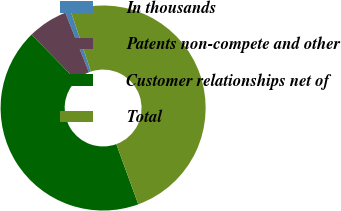Convert chart to OTSL. <chart><loc_0><loc_0><loc_500><loc_500><pie_chart><fcel>In thousands<fcel>Patents non-compete and other<fcel>Customer relationships net of<fcel>Total<nl><fcel>0.88%<fcel>6.28%<fcel>43.28%<fcel>49.56%<nl></chart> 